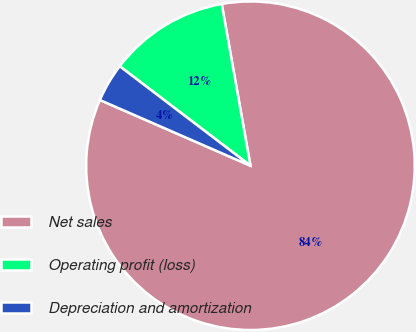Convert chart to OTSL. <chart><loc_0><loc_0><loc_500><loc_500><pie_chart><fcel>Net sales<fcel>Operating profit (loss)<fcel>Depreciation and amortization<nl><fcel>84.35%<fcel>11.85%<fcel>3.8%<nl></chart> 